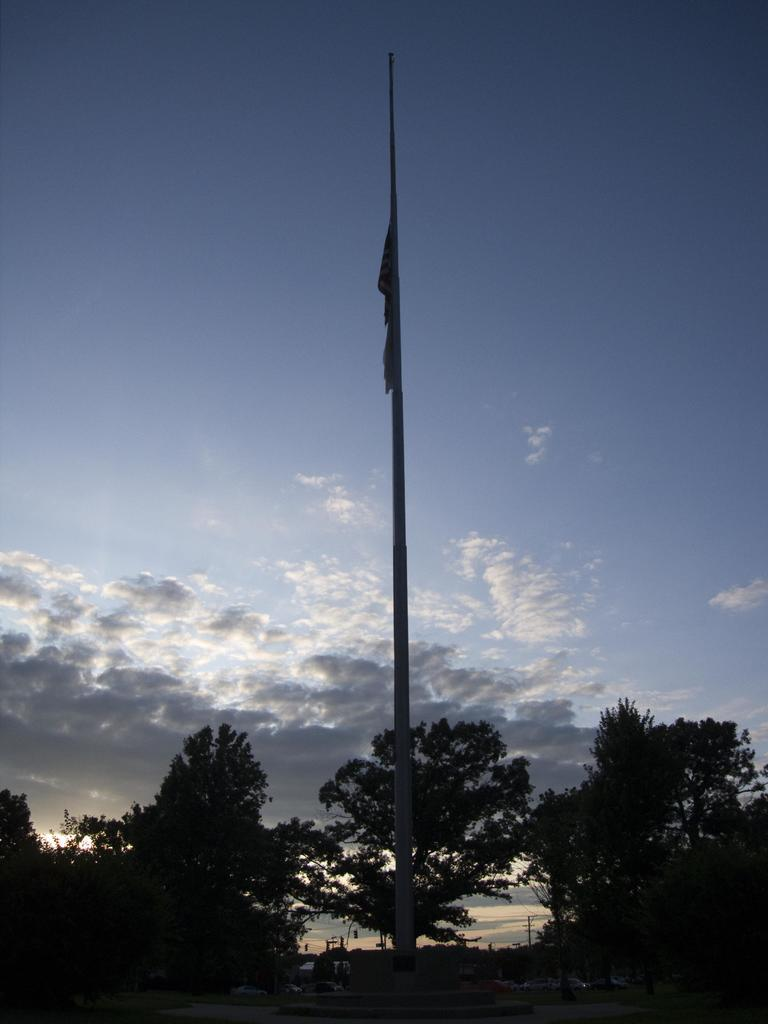What is the main object in the center of the image? There is a pole in the center of the image. What is attached to the pole? A flag is attached to the pole. What can be seen in the background of the image? There are trees in the background of the image. How would you describe the sky in the image? The sky is cloudy in the background of the image. What type of vest is the pole wearing in the image? The pole is not wearing a vest, as it is an inanimate object and does not have the ability to wear clothing. 